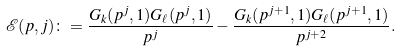<formula> <loc_0><loc_0><loc_500><loc_500>\mathcal { E } ( p , j ) \colon = \frac { G _ { k } ( p ^ { j } , 1 ) G _ { \ell } ( p ^ { j } , 1 ) } { p ^ { j } } - \frac { G _ { k } ( p ^ { j + 1 } , 1 ) G _ { \ell } ( p ^ { j + 1 } , 1 ) } { p ^ { j + 2 } } .</formula> 